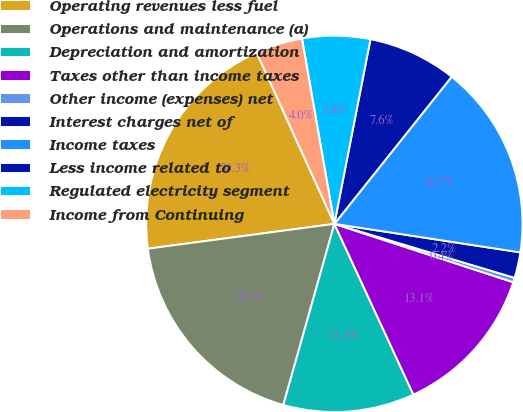Convert chart. <chart><loc_0><loc_0><loc_500><loc_500><pie_chart><fcel>Operating revenues less fuel<fcel>Operations and maintenance (a)<fcel>Depreciation and amortization<fcel>Taxes other than income taxes<fcel>Other income (expenses) net<fcel>Interest charges net of<fcel>Income taxes<fcel>Less income related to<fcel>Regulated electricity segment<fcel>Income from Continuing<nl><fcel>20.33%<fcel>18.52%<fcel>11.27%<fcel>13.08%<fcel>0.39%<fcel>2.21%<fcel>16.71%<fcel>7.64%<fcel>5.83%<fcel>4.02%<nl></chart> 